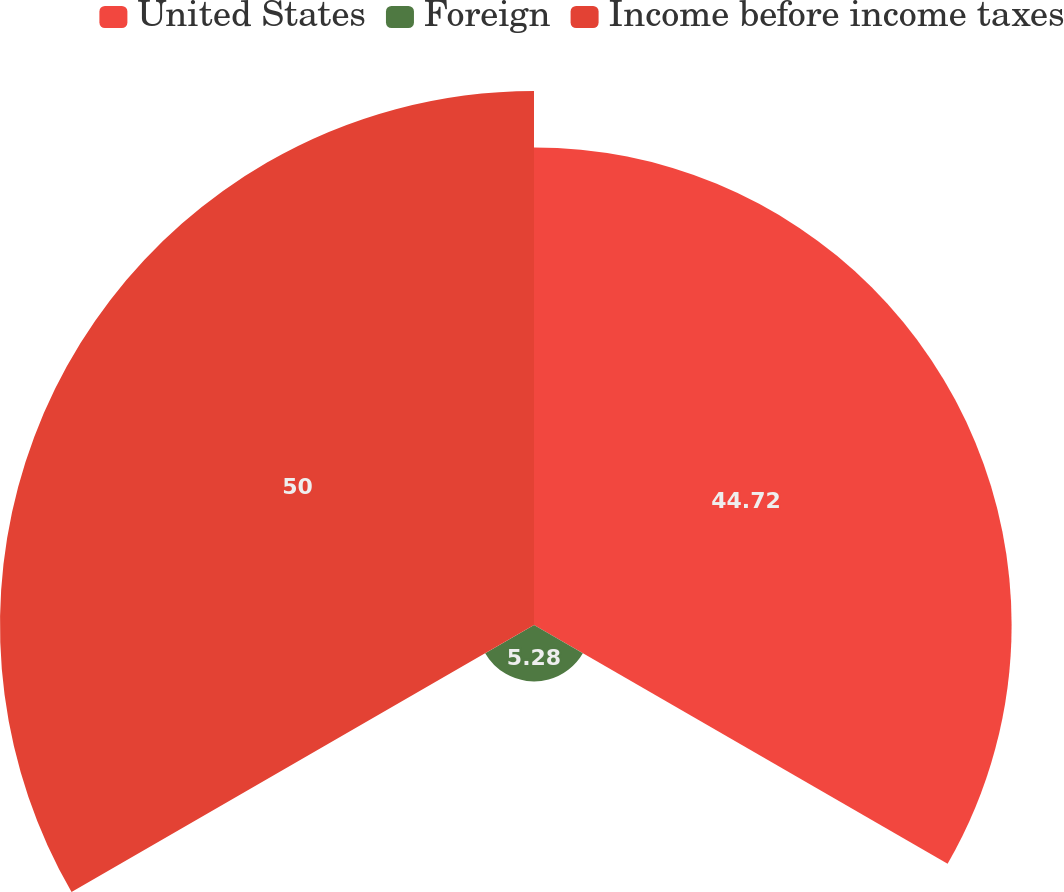Convert chart to OTSL. <chart><loc_0><loc_0><loc_500><loc_500><pie_chart><fcel>United States<fcel>Foreign<fcel>Income before income taxes<nl><fcel>44.72%<fcel>5.28%<fcel>50.0%<nl></chart> 